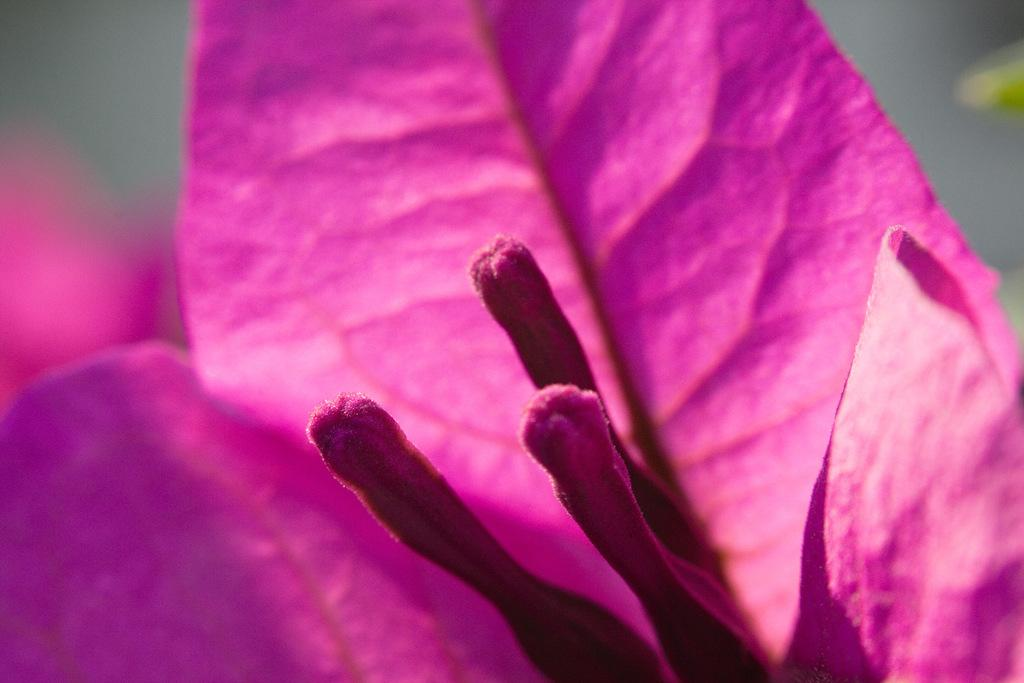What type of image is being shown? The image is a zoom-in picture. What is the main subject of the image? The subject of the image is a pink flower. Reasoning: Let' Let's think step by step in order to produce the conversation. We start by identifying the type of image being shown, which is a zoom-in picture. Then, we focus on the main subject of the image, which is a pink flower. We keep the questions simple and clear, ensuring that each question can be answered definitively with the information given. Absurd Question/Answer: How does the wealth of the flower affect its appearance in the image? The image does not provide any information about the wealth of the flower, and therefore it cannot be determined how wealth might affect its appearance. 